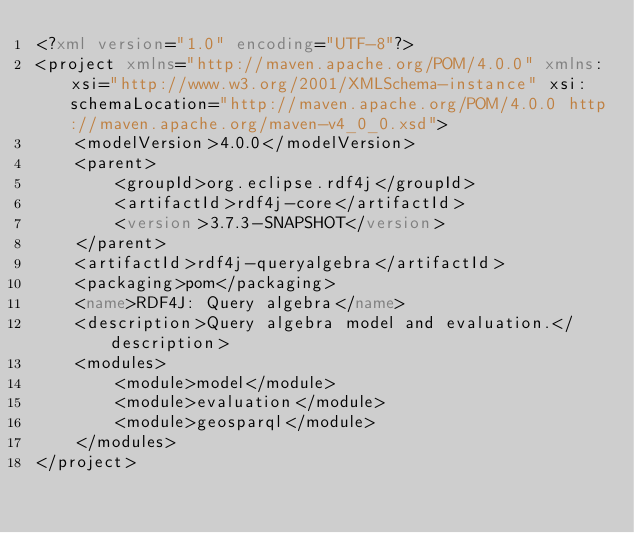Convert code to text. <code><loc_0><loc_0><loc_500><loc_500><_XML_><?xml version="1.0" encoding="UTF-8"?>
<project xmlns="http://maven.apache.org/POM/4.0.0" xmlns:xsi="http://www.w3.org/2001/XMLSchema-instance" xsi:schemaLocation="http://maven.apache.org/POM/4.0.0 http://maven.apache.org/maven-v4_0_0.xsd">
	<modelVersion>4.0.0</modelVersion>
	<parent>
		<groupId>org.eclipse.rdf4j</groupId>
		<artifactId>rdf4j-core</artifactId>
		<version>3.7.3-SNAPSHOT</version>
	</parent>
	<artifactId>rdf4j-queryalgebra</artifactId>
	<packaging>pom</packaging>
	<name>RDF4J: Query algebra</name>
	<description>Query algebra model and evaluation.</description>
	<modules>
		<module>model</module>
		<module>evaluation</module>
		<module>geosparql</module>
	</modules>
</project>
</code> 